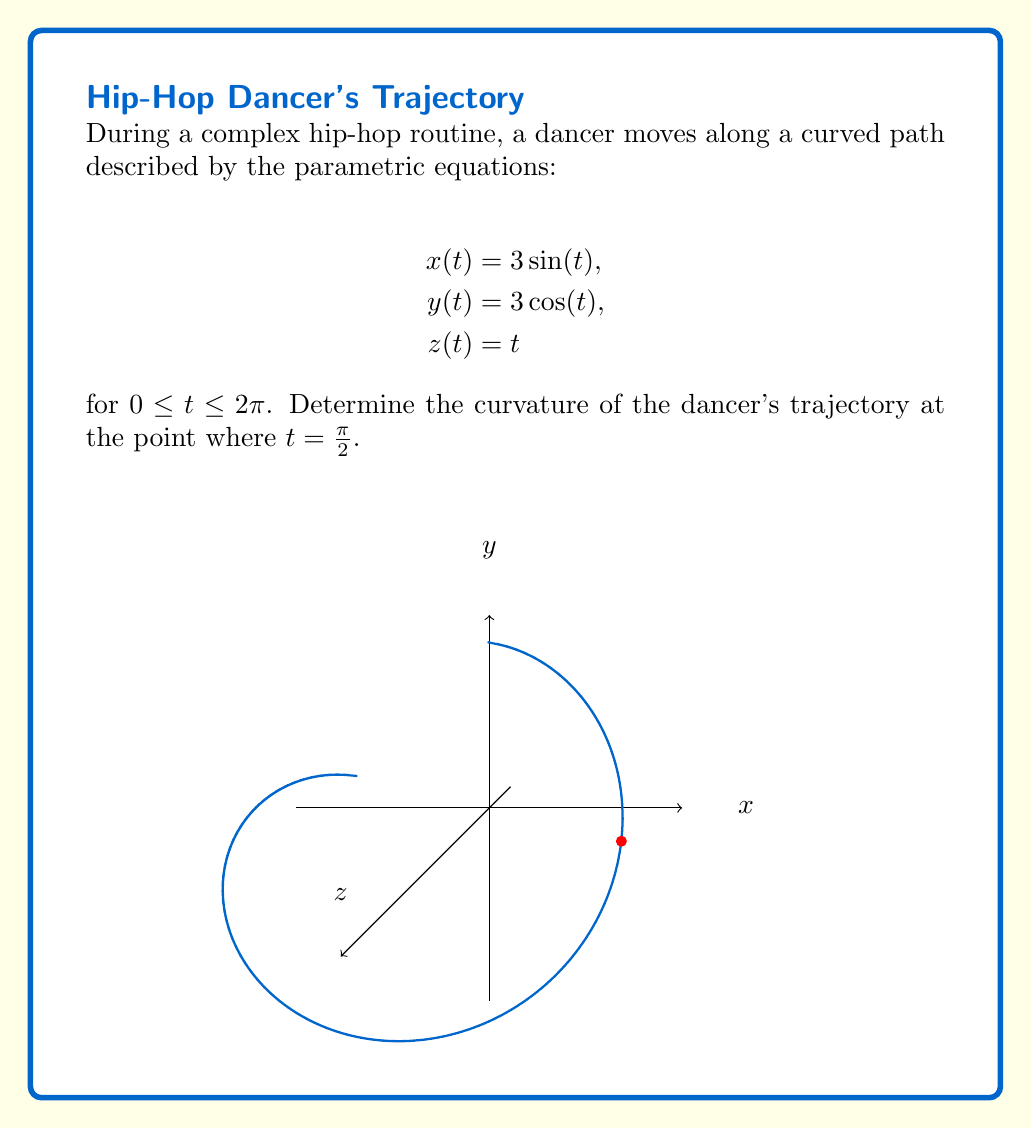What is the answer to this math problem? To find the curvature of the dancer's trajectory, we'll follow these steps:

1) The curvature formula for a space curve is:

   $$\kappa = \frac{|\mathbf{r}'(t) \times \mathbf{r}''(t)|}{|\mathbf{r}'(t)|^3}$$

2) First, let's find $\mathbf{r}'(t)$:
   $$\mathbf{r}'(t) = (3\cos(t), -3\sin(t), 1)$$

3) Now, let's find $\mathbf{r}''(t)$:
   $$\mathbf{r}''(t) = (-3\sin(t), -3\cos(t), 0)$$

4) At $t = \frac{\pi}{2}$:
   $$\mathbf{r}'(\frac{\pi}{2}) = (0, -3, 1)$$
   $$\mathbf{r}''(\frac{\pi}{2}) = (-3, 0, 0)$$

5) Calculate the cross product $\mathbf{r}'(\frac{\pi}{2}) \times \mathbf{r}''(\frac{\pi}{2})$:
   $$(0, -3, 1) \times (-3, 0, 0) = (0, -3, 9)$$

6) Find the magnitude of this cross product:
   $$|\mathbf{r}'(\frac{\pi}{2}) \times \mathbf{r}''(\frac{\pi}{2})| = \sqrt{0^2 + (-3)^2 + 9^2} = \sqrt{90} = 3\sqrt{10}$$

7) Calculate $|\mathbf{r}'(\frac{\pi}{2})|^3$:
   $$|\mathbf{r}'(\frac{\pi}{2})|^3 = ({\sqrt{0^2 + (-3)^2 + 1^2}})^3 = (\sqrt{10})^3 = 10\sqrt{10}$$

8) Now, we can plug these values into the curvature formula:
   $$\kappa = \frac{3\sqrt{10}}{10\sqrt{10}} = \frac{3}{10}$$

Therefore, the curvature of the dancer's trajectory at $t = \frac{\pi}{2}$ is $\frac{3}{10}$.
Answer: $\frac{3}{10}$ 